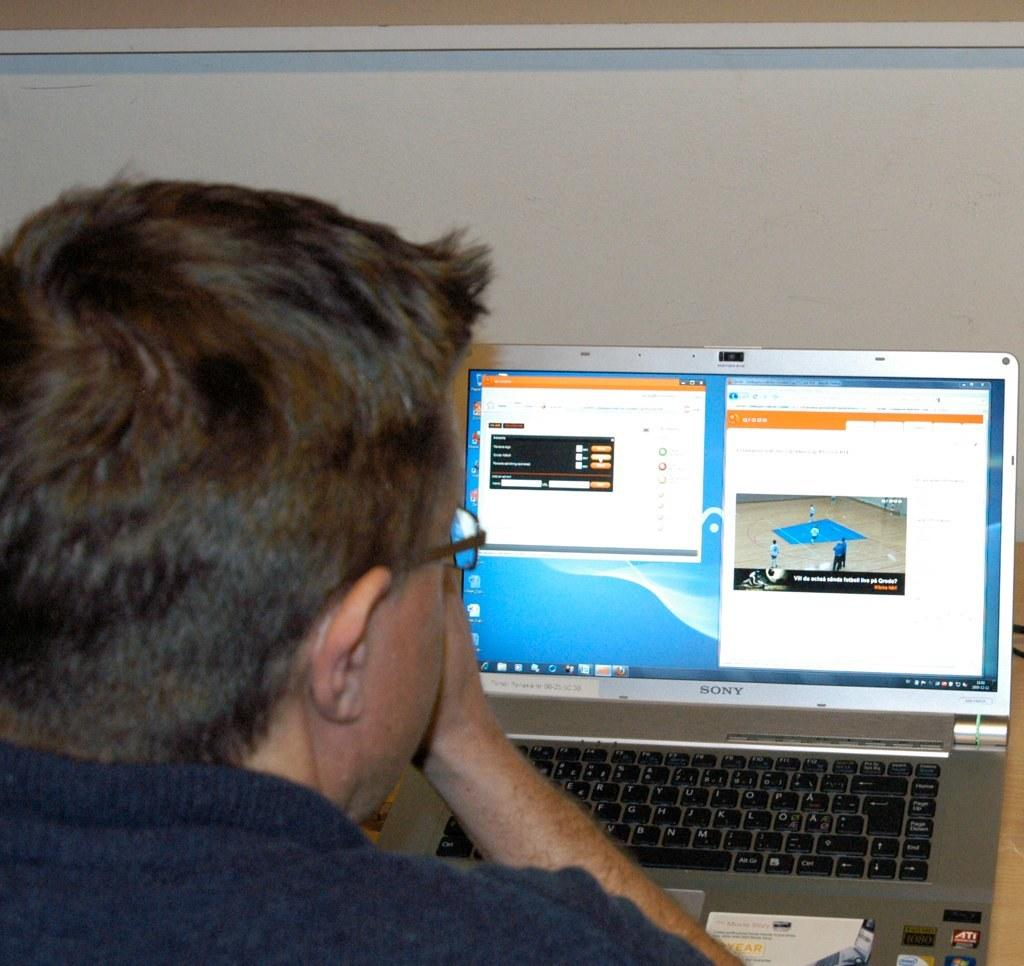<image>
Provide a brief description of the given image. a man in front of a Sony lap top computer 